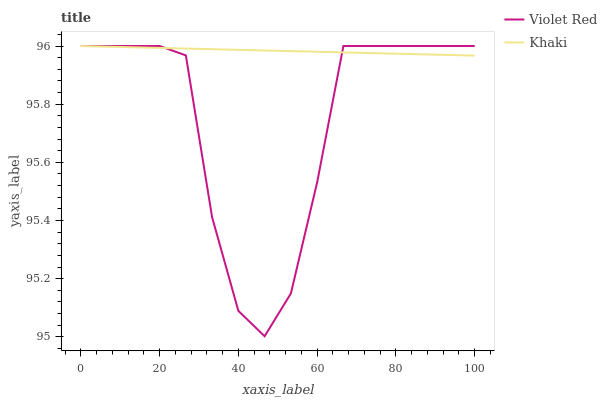Does Violet Red have the minimum area under the curve?
Answer yes or no. Yes. Does Khaki have the maximum area under the curve?
Answer yes or no. Yes. Does Khaki have the minimum area under the curve?
Answer yes or no. No. Is Khaki the smoothest?
Answer yes or no. Yes. Is Violet Red the roughest?
Answer yes or no. Yes. Is Khaki the roughest?
Answer yes or no. No. Does Khaki have the lowest value?
Answer yes or no. No. 